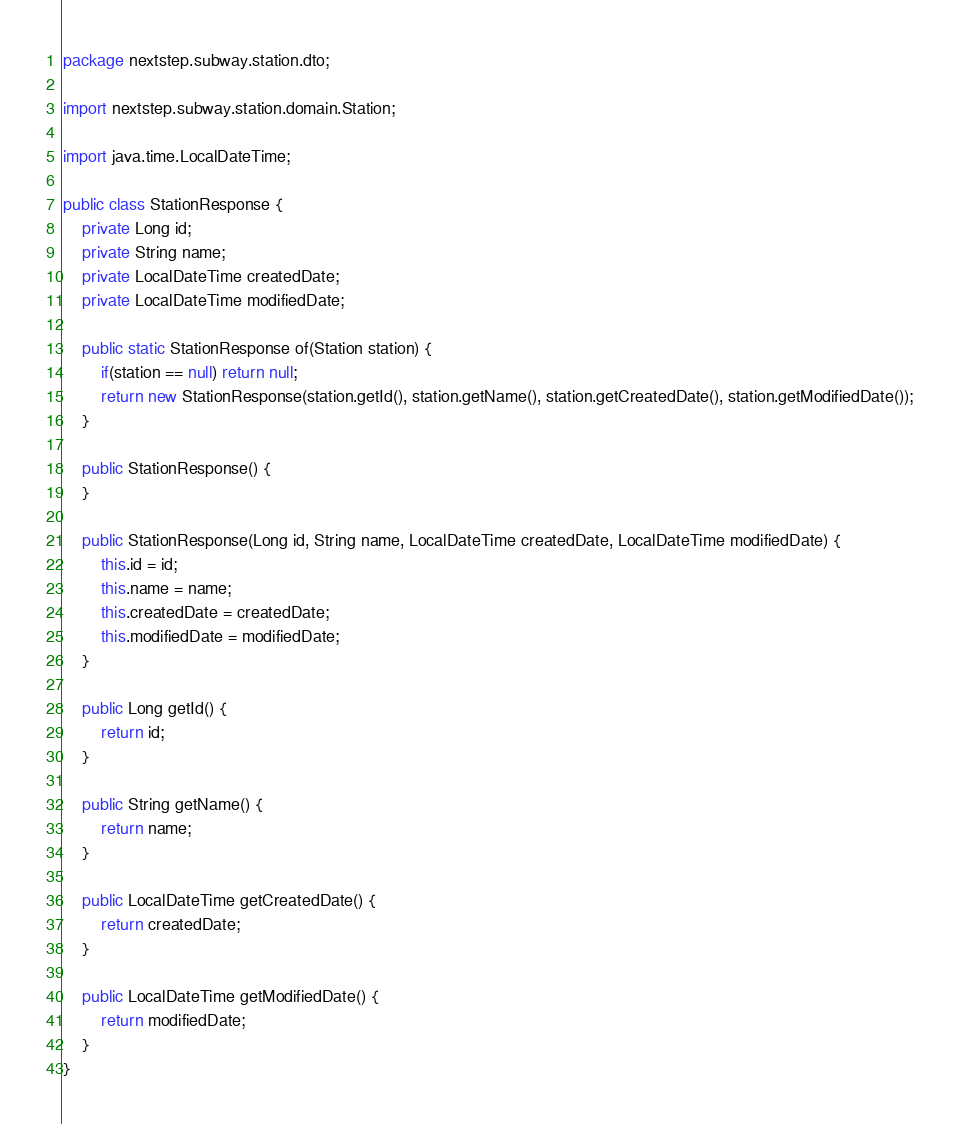<code> <loc_0><loc_0><loc_500><loc_500><_Java_>package nextstep.subway.station.dto;

import nextstep.subway.station.domain.Station;

import java.time.LocalDateTime;

public class StationResponse {
    private Long id;
    private String name;
    private LocalDateTime createdDate;
    private LocalDateTime modifiedDate;

    public static StationResponse of(Station station) {
        if(station == null) return null;
        return new StationResponse(station.getId(), station.getName(), station.getCreatedDate(), station.getModifiedDate());
    }

    public StationResponse() {
    }

    public StationResponse(Long id, String name, LocalDateTime createdDate, LocalDateTime modifiedDate) {
        this.id = id;
        this.name = name;
        this.createdDate = createdDate;
        this.modifiedDate = modifiedDate;
    }

    public Long getId() {
        return id;
    }

    public String getName() {
        return name;
    }

    public LocalDateTime getCreatedDate() {
        return createdDate;
    }

    public LocalDateTime getModifiedDate() {
        return modifiedDate;
    }
}
</code> 